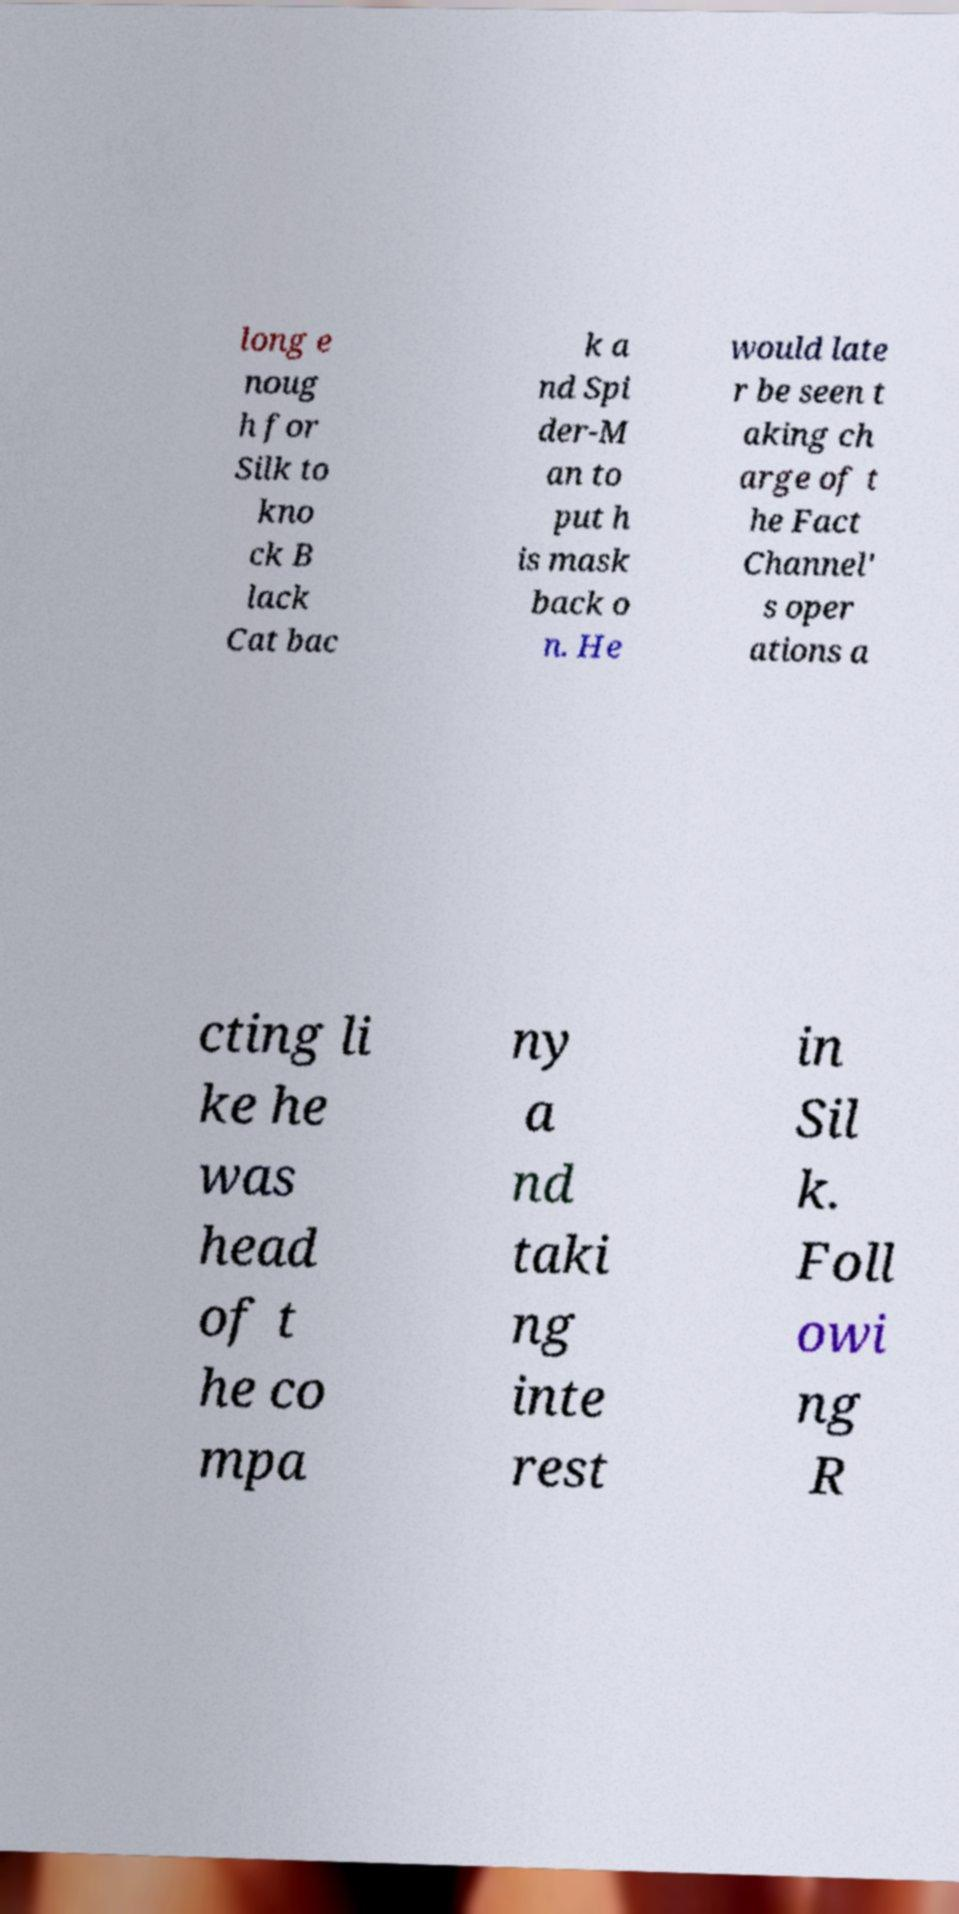Can you read and provide the text displayed in the image?This photo seems to have some interesting text. Can you extract and type it out for me? long e noug h for Silk to kno ck B lack Cat bac k a nd Spi der-M an to put h is mask back o n. He would late r be seen t aking ch arge of t he Fact Channel' s oper ations a cting li ke he was head of t he co mpa ny a nd taki ng inte rest in Sil k. Foll owi ng R 